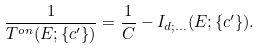Convert formula to latex. <formula><loc_0><loc_0><loc_500><loc_500>\frac { 1 } { T ^ { o n } ( E ; \{ c ^ { \prime } \} ) } = \frac { 1 } { C } - I _ { d ; \dots } ( E ; \{ c ^ { \prime } \} ) .</formula> 